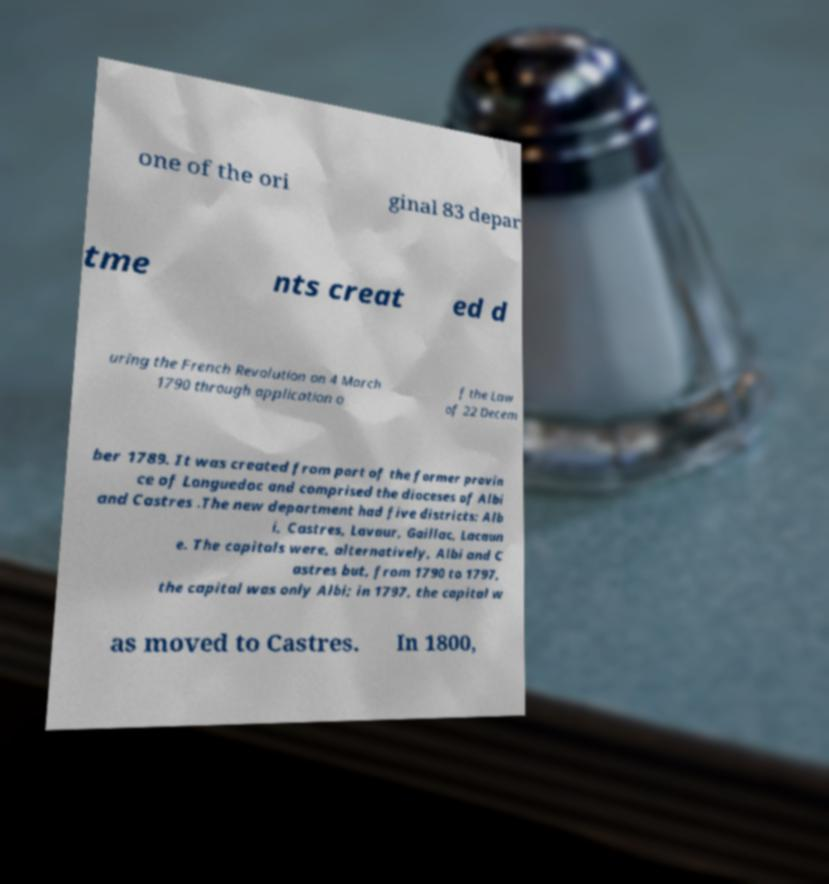Could you extract and type out the text from this image? one of the ori ginal 83 depar tme nts creat ed d uring the French Revolution on 4 March 1790 through application o f the Law of 22 Decem ber 1789. It was created from part of the former provin ce of Languedoc and comprised the dioceses of Albi and Castres .The new department had five districts: Alb i, Castres, Lavaur, Gaillac, Lacaun e. The capitals were, alternatively, Albi and C astres but, from 1790 to 1797, the capital was only Albi; in 1797, the capital w as moved to Castres. In 1800, 